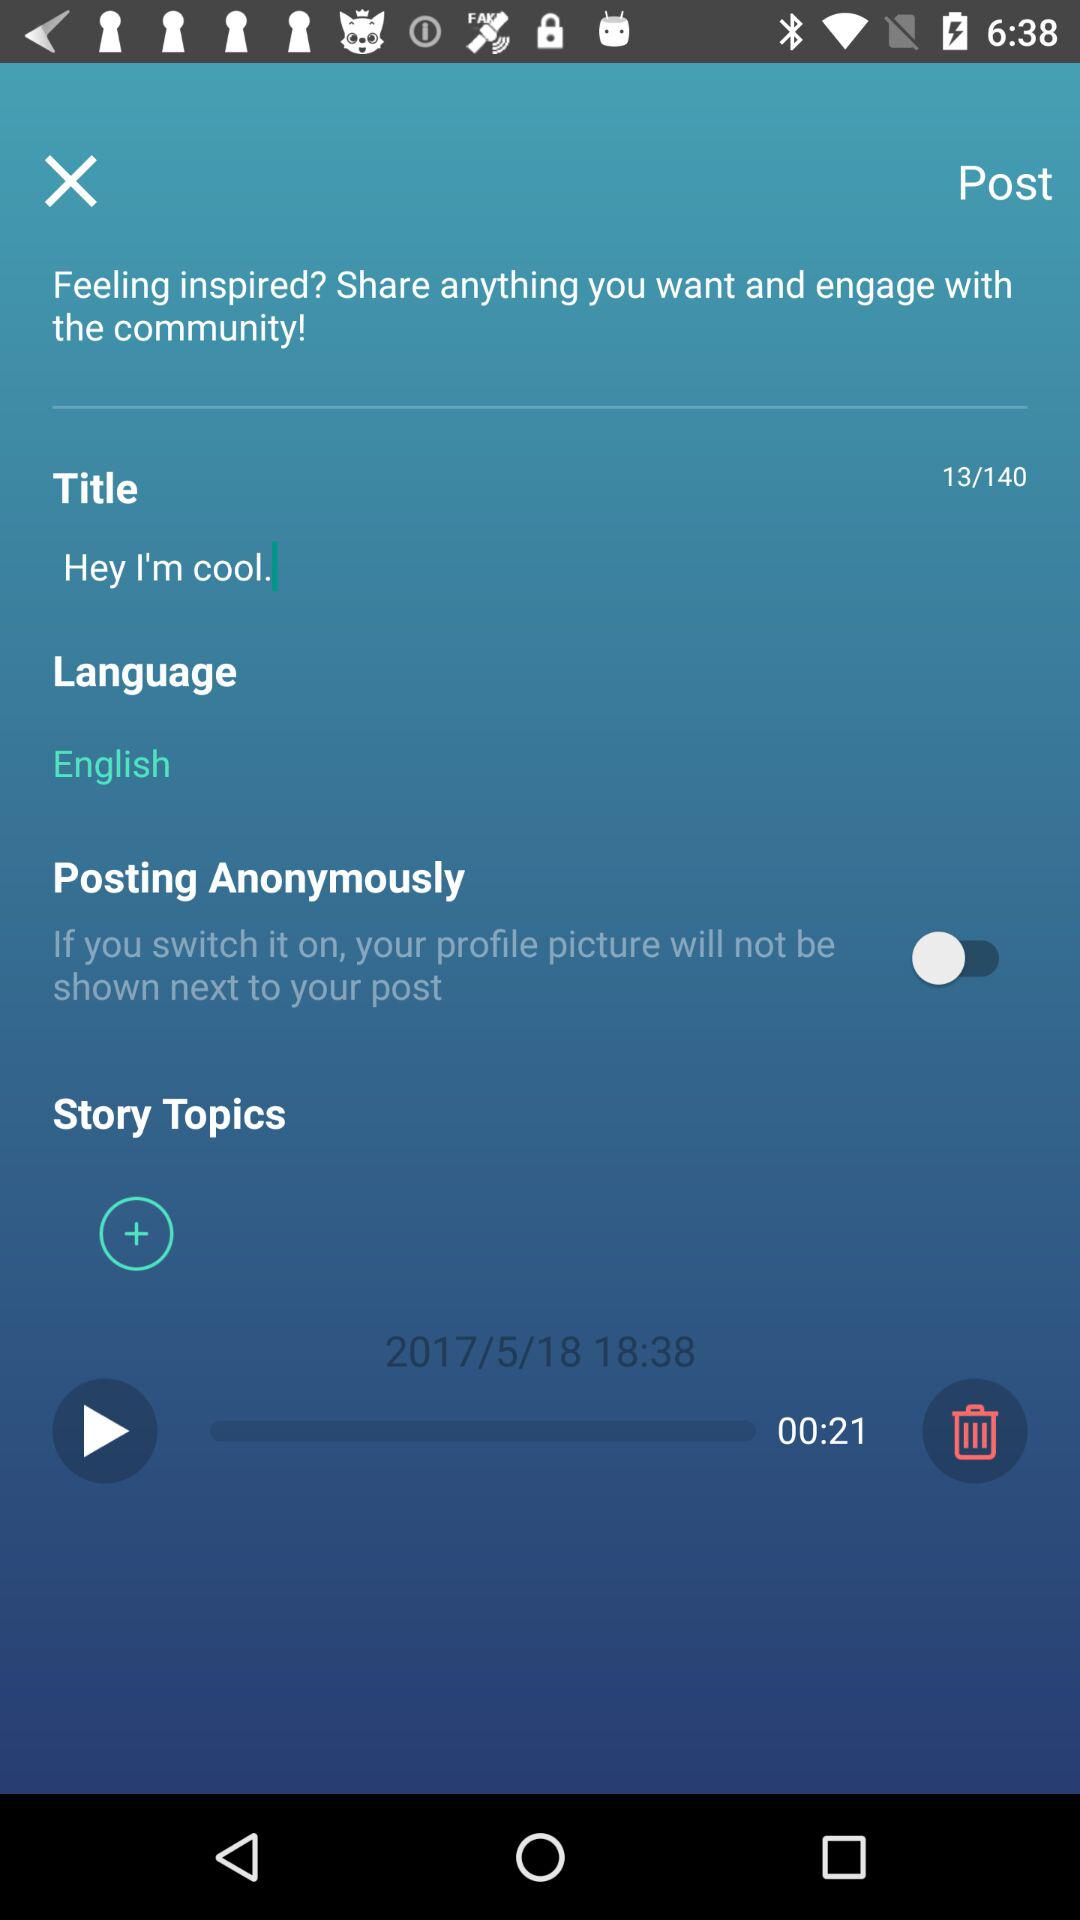What is the duration of the story? The duration of the story is 21 seconds. 